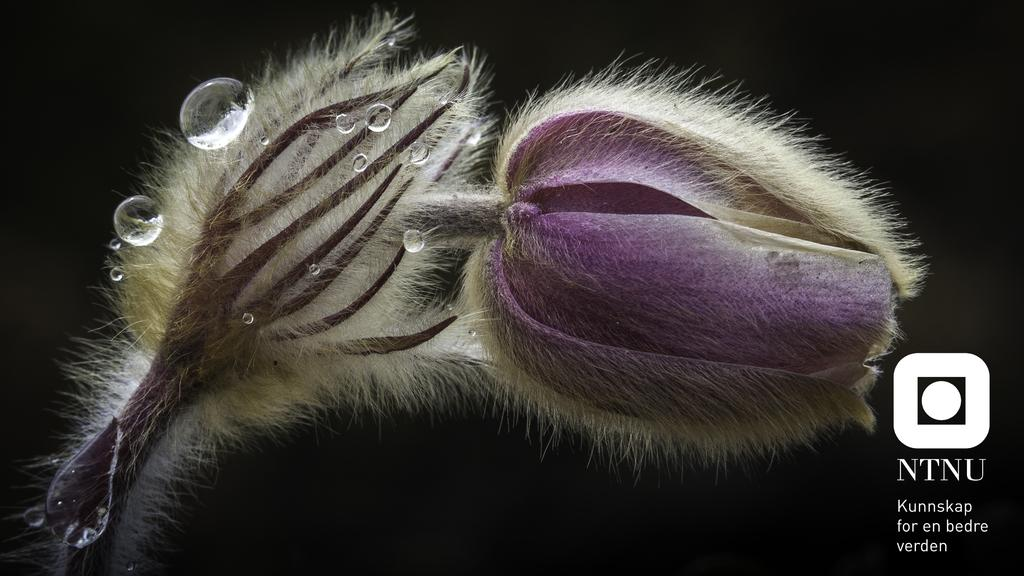What is the main subject of the image? There is a flower in the image. What can be observed on the flower? There are water-droplets on the flower. How would you describe the background of the image? The background of the image is dark. Is there any additional information or branding present in the image? Yes, there is a watermark with a logo on the right side of the image. What type of experience does the earth have with the flower in the image? The image does not depict the earth or any interaction between the earth and the flower, so it is not possible to answer this question. 